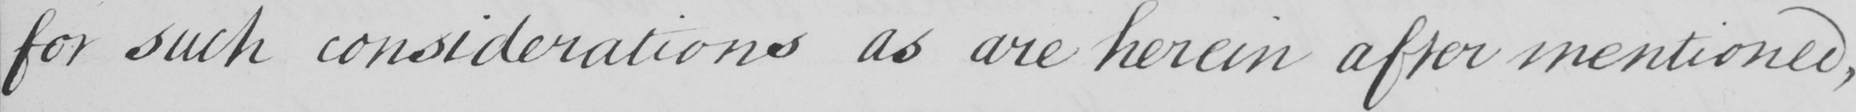What does this handwritten line say? for such considerations as are herein after mentioned, 